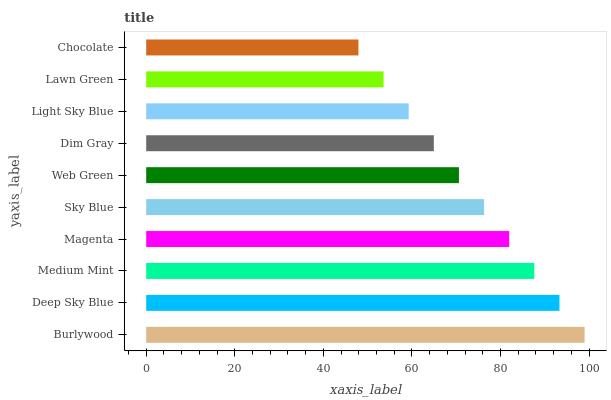Is Chocolate the minimum?
Answer yes or no. Yes. Is Burlywood the maximum?
Answer yes or no. Yes. Is Deep Sky Blue the minimum?
Answer yes or no. No. Is Deep Sky Blue the maximum?
Answer yes or no. No. Is Burlywood greater than Deep Sky Blue?
Answer yes or no. Yes. Is Deep Sky Blue less than Burlywood?
Answer yes or no. Yes. Is Deep Sky Blue greater than Burlywood?
Answer yes or no. No. Is Burlywood less than Deep Sky Blue?
Answer yes or no. No. Is Sky Blue the high median?
Answer yes or no. Yes. Is Web Green the low median?
Answer yes or no. Yes. Is Web Green the high median?
Answer yes or no. No. Is Lawn Green the low median?
Answer yes or no. No. 